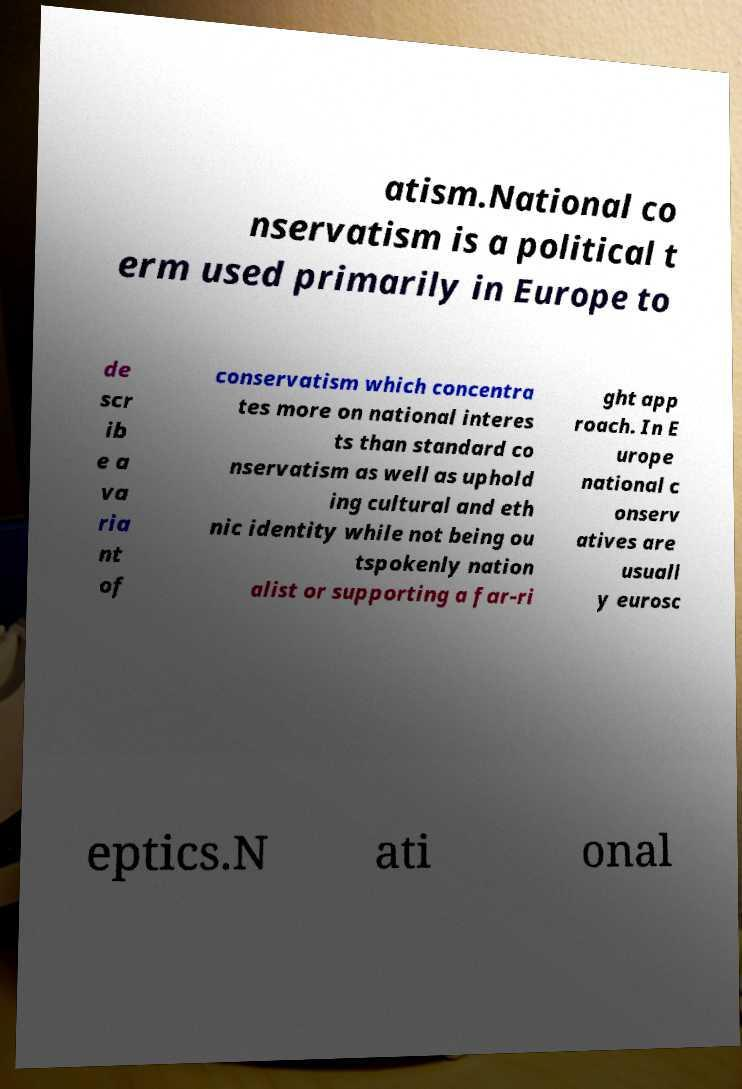There's text embedded in this image that I need extracted. Can you transcribe it verbatim? atism.National co nservatism is a political t erm used primarily in Europe to de scr ib e a va ria nt of conservatism which concentra tes more on national interes ts than standard co nservatism as well as uphold ing cultural and eth nic identity while not being ou tspokenly nation alist or supporting a far-ri ght app roach. In E urope national c onserv atives are usuall y eurosc eptics.N ati onal 